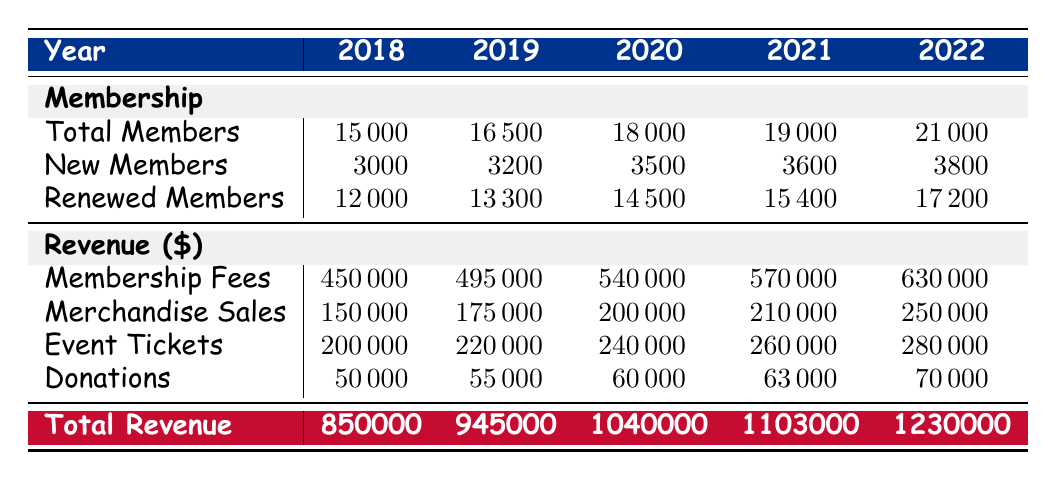What was the total number of members in the Buffalo Bills Fan Club in 2020? In the "Total Members" row for the year 2020, the table shows a value of 18000.
Answer: 18000 How many new members joined the Buffalo Bills Fan Club in 2021? The "New Members" row indicates that there were 3600 new members in 2021.
Answer: 3600 What is the total revenue for the Buffalo Bills Fan Club in 2022? The "Total Revenue" row for 2022 shows a value of 1230000.
Answer: 1230000 Is the merchandise sales revenue higher in 2022 than in 2019? By comparing the values, merchandise sales in 2022 is 250000 while in 2019 it is 175000, so yes, it is higher.
Answer: Yes What was the average increase of new members per year from 2018 to 2022? The new member counts for the years are 3000, 3200, 3500, 3600, and 3800. Their total is 3000 + 3200 + 3500 + 3600 + 3800 = 17100. Dividing by 5 gives an average of 3420.
Answer: 3420 What percentage of total members were renewed in 2022? In 2022, the total members are 21000 and renewed members are 17200. The percentage of renewed members is (17200 / 21000) * 100 = 81.90%.
Answer: 81.90% What is the difference in membership fees revenue between 2018 and 2020? The revenue from membership fees in 2018 is 450000, and in 2020 it is 540000. The difference is 540000 - 450000 = 90000.
Answer: 90000 Did the Buffalo Bills Fan Club increase its total revenue every year from 2018 to 2022? By looking at the total revenue values for each year, they consistently rise from 850000 in 2018 to 1230000 in 2022, indicating a consistent increase.
Answer: Yes What was the total growth in the number of total members from 2018 to 2022? The total members in 2018 were 15000, and in 2022 they were 21000. The growth is 21000 - 15000 = 6000.
Answer: 6000 In which year did the Buffalo Bills Fan Club generate revenue from donations at its highest point? Looking at the "Donations" row, in 2022 the revenue is 70000, which is higher compared to the previous years.
Answer: 2022 